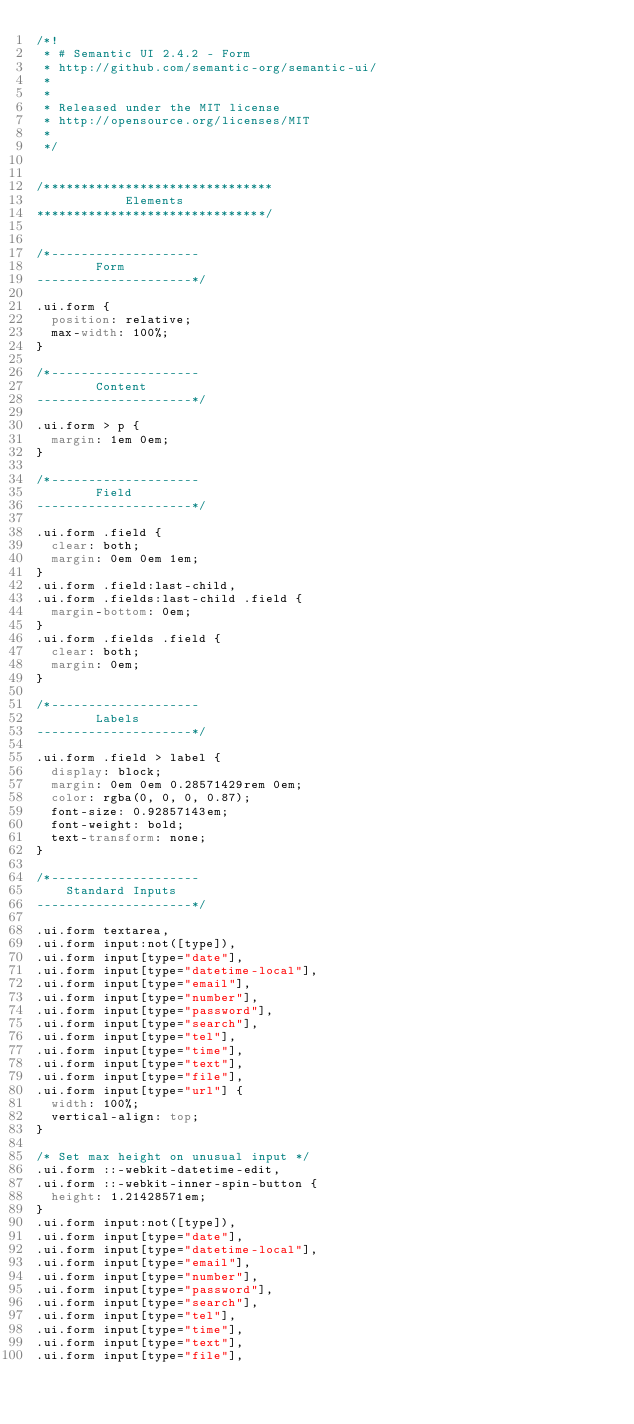<code> <loc_0><loc_0><loc_500><loc_500><_CSS_>/*!
 * # Semantic UI 2.4.2 - Form
 * http://github.com/semantic-org/semantic-ui/
 *
 *
 * Released under the MIT license
 * http://opensource.org/licenses/MIT
 *
 */


/*******************************
            Elements
*******************************/


/*--------------------
        Form
---------------------*/

.ui.form {
  position: relative;
  max-width: 100%;
}

/*--------------------
        Content
---------------------*/

.ui.form > p {
  margin: 1em 0em;
}

/*--------------------
        Field
---------------------*/

.ui.form .field {
  clear: both;
  margin: 0em 0em 1em;
}
.ui.form .field:last-child,
.ui.form .fields:last-child .field {
  margin-bottom: 0em;
}
.ui.form .fields .field {
  clear: both;
  margin: 0em;
}

/*--------------------
        Labels
---------------------*/

.ui.form .field > label {
  display: block;
  margin: 0em 0em 0.28571429rem 0em;
  color: rgba(0, 0, 0, 0.87);
  font-size: 0.92857143em;
  font-weight: bold;
  text-transform: none;
}

/*--------------------
    Standard Inputs
---------------------*/

.ui.form textarea,
.ui.form input:not([type]),
.ui.form input[type="date"],
.ui.form input[type="datetime-local"],
.ui.form input[type="email"],
.ui.form input[type="number"],
.ui.form input[type="password"],
.ui.form input[type="search"],
.ui.form input[type="tel"],
.ui.form input[type="time"],
.ui.form input[type="text"],
.ui.form input[type="file"],
.ui.form input[type="url"] {
  width: 100%;
  vertical-align: top;
}

/* Set max height on unusual input */
.ui.form ::-webkit-datetime-edit,
.ui.form ::-webkit-inner-spin-button {
  height: 1.21428571em;
}
.ui.form input:not([type]),
.ui.form input[type="date"],
.ui.form input[type="datetime-local"],
.ui.form input[type="email"],
.ui.form input[type="number"],
.ui.form input[type="password"],
.ui.form input[type="search"],
.ui.form input[type="tel"],
.ui.form input[type="time"],
.ui.form input[type="text"],
.ui.form input[type="file"],</code> 